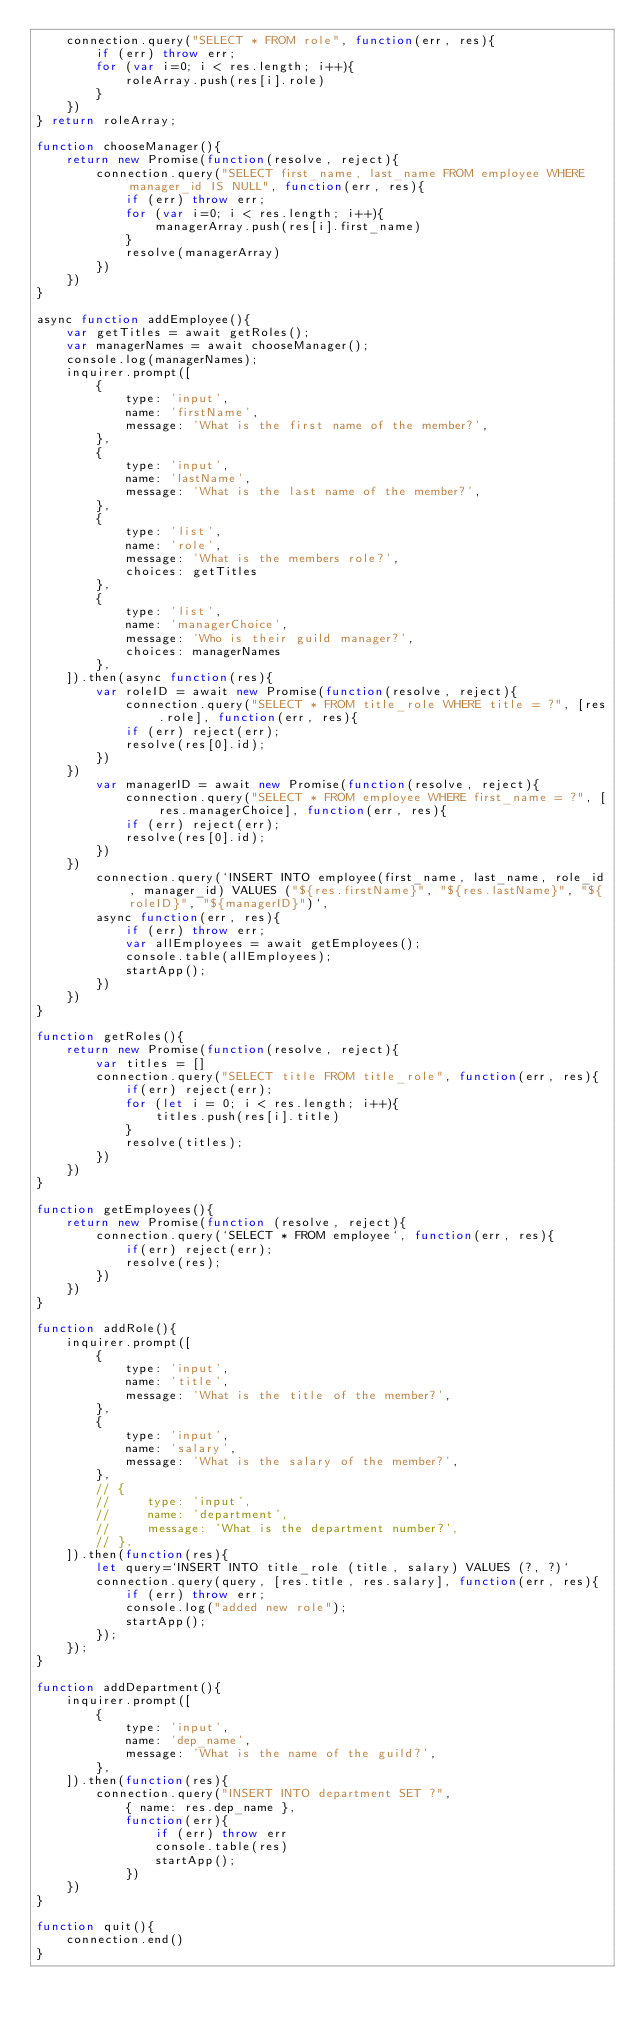Convert code to text. <code><loc_0><loc_0><loc_500><loc_500><_JavaScript_>    connection.query("SELECT * FROM role", function(err, res){
        if (err) throw err;
        for (var i=0; i < res.length; i++){
            roleArray.push(res[i].role)
        }
    })
} return roleArray;

function chooseManager(){
    return new Promise(function(resolve, reject){
        connection.query("SELECT first_name, last_name FROM employee WHERE manager_id IS NULL", function(err, res){
            if (err) throw err;
            for (var i=0; i < res.length; i++){
                managerArray.push(res[i].first_name)
            }
            resolve(managerArray)
        })
    })  
}

async function addEmployee(){
    var getTitles = await getRoles();
    var managerNames = await chooseManager();
    console.log(managerNames);
    inquirer.prompt([
        {
            type: 'input',
            name: 'firstName',
            message: 'What is the first name of the member?',
        },
        {
            type: 'input',
            name: 'lastName',
            message: 'What is the last name of the member?',
        },
        {
            type: 'list',
            name: 'role',
            message: 'What is the members role?',
            choices: getTitles
        },
        {
            type: 'list',
            name: 'managerChoice',
            message: 'Who is their guild manager?',
            choices: managerNames
        },
    ]).then(async function(res){
        var roleID = await new Promise(function(resolve, reject){
            connection.query("SELECT * FROM title_role WHERE title = ?", [res.role], function(err, res){
            if (err) reject(err);
            resolve(res[0].id);
        })
    })
        var managerID = await new Promise(function(resolve, reject){
            connection.query("SELECT * FROM employee WHERE first_name = ?", [res.managerChoice], function(err, res){
            if (err) reject(err);
            resolve(res[0].id);
        })
    })
        connection.query(`INSERT INTO employee(first_name, last_name, role_id, manager_id) VALUES ("${res.firstName}", "${res.lastName}", "${roleID}", "${managerID}")`,
        async function(err, res){
            if (err) throw err;
            var allEmployees = await getEmployees();
            console.table(allEmployees);
            startApp();
        })
    })
}    

function getRoles(){
    return new Promise(function(resolve, reject){
        var titles = []
        connection.query("SELECT title FROM title_role", function(err, res){
            if(err) reject(err);
            for (let i = 0; i < res.length; i++){
                titles.push(res[i].title)
            } 
            resolve(titles);
        })
    })
}

function getEmployees(){
    return new Promise(function (resolve, reject){
        connection.query(`SELECT * FROM employee`, function(err, res){
            if(err) reject(err);
            resolve(res);
        })
    })
}

function addRole(){
    inquirer.prompt([
        {
            type: 'input',
            name: 'title',
            message: 'What is the title of the member?',
        },
        {
            type: 'input',
            name: 'salary',
            message: 'What is the salary of the member?',
        },
        // {
        //     type: 'input',
        //     name: 'department',
        //     message: 'What is the department number?',
        // },
    ]).then(function(res){
        let query=`INSERT INTO title_role (title, salary) VALUES (?, ?)`
        connection.query(query, [res.title, res.salary], function(err, res){
            if (err) throw err;
            console.log("added new role");
            startApp(); 
        });
    });
}

function addDepartment(){
    inquirer.prompt([
        {
            type: 'input',
            name: 'dep_name',
            message: 'What is the name of the guild?',
        },
    ]).then(function(res){
        connection.query("INSERT INTO department SET ?",
            { name: res.dep_name }, 
            function(err){
                if (err) throw err
                console.table(res)
                startApp();
            })
    })
}

function quit(){
    connection.end()
}

</code> 